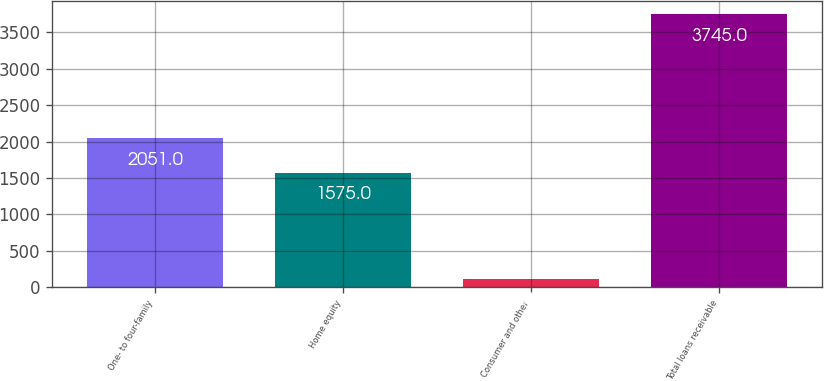Convert chart. <chart><loc_0><loc_0><loc_500><loc_500><bar_chart><fcel>One- to four-family<fcel>Home equity<fcel>Consumer and other<fcel>Total loans receivable<nl><fcel>2051<fcel>1575<fcel>119<fcel>3745<nl></chart> 